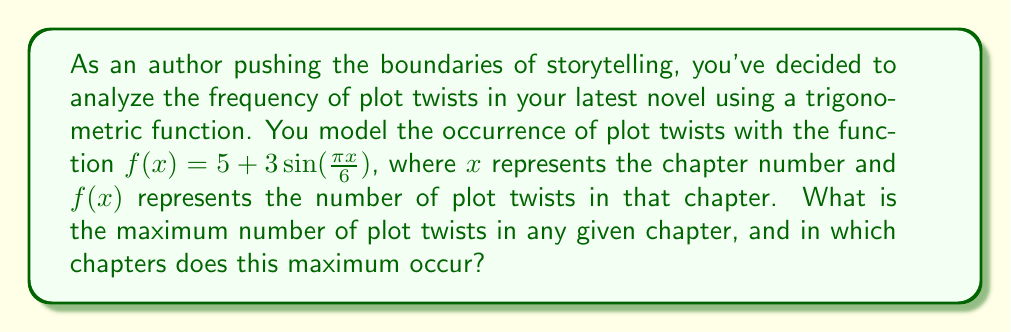Help me with this question. To solve this problem, we'll follow these steps:

1) The general form of a sine function is:
   $$f(x) = A\sin(Bx) + C$$
   where $A$ is the amplitude, $B$ is the frequency, and $C$ is the vertical shift.

2) In our function $f(x) = 5 + 3\sin(\frac{\pi x}{6})$:
   - The amplitude $A = 3$
   - The vertical shift $C = 5$

3) The maximum value of a sine function occurs when $\sin(Bx) = 1$.

4) The maximum value of our function will be:
   $$f_{max} = C + A = 5 + 3 = 8$$

5) To find the chapters where this maximum occurs, we need to solve:
   $$\frac{\pi x}{6} = \frac{\pi}{2} + 2\pi n$$
   where $n$ is any integer.

6) Solving for $x$:
   $$x = 3 + 12n$$
   where $n$ is any integer.

7) Since chapters are numbered positively, the first few occurrences of the maximum will be at chapters 3, 15, 27, 39, and so on.
Answer: Maximum: 8 plot twists; Occurs in chapters 3, 15, 27, 39, ... 